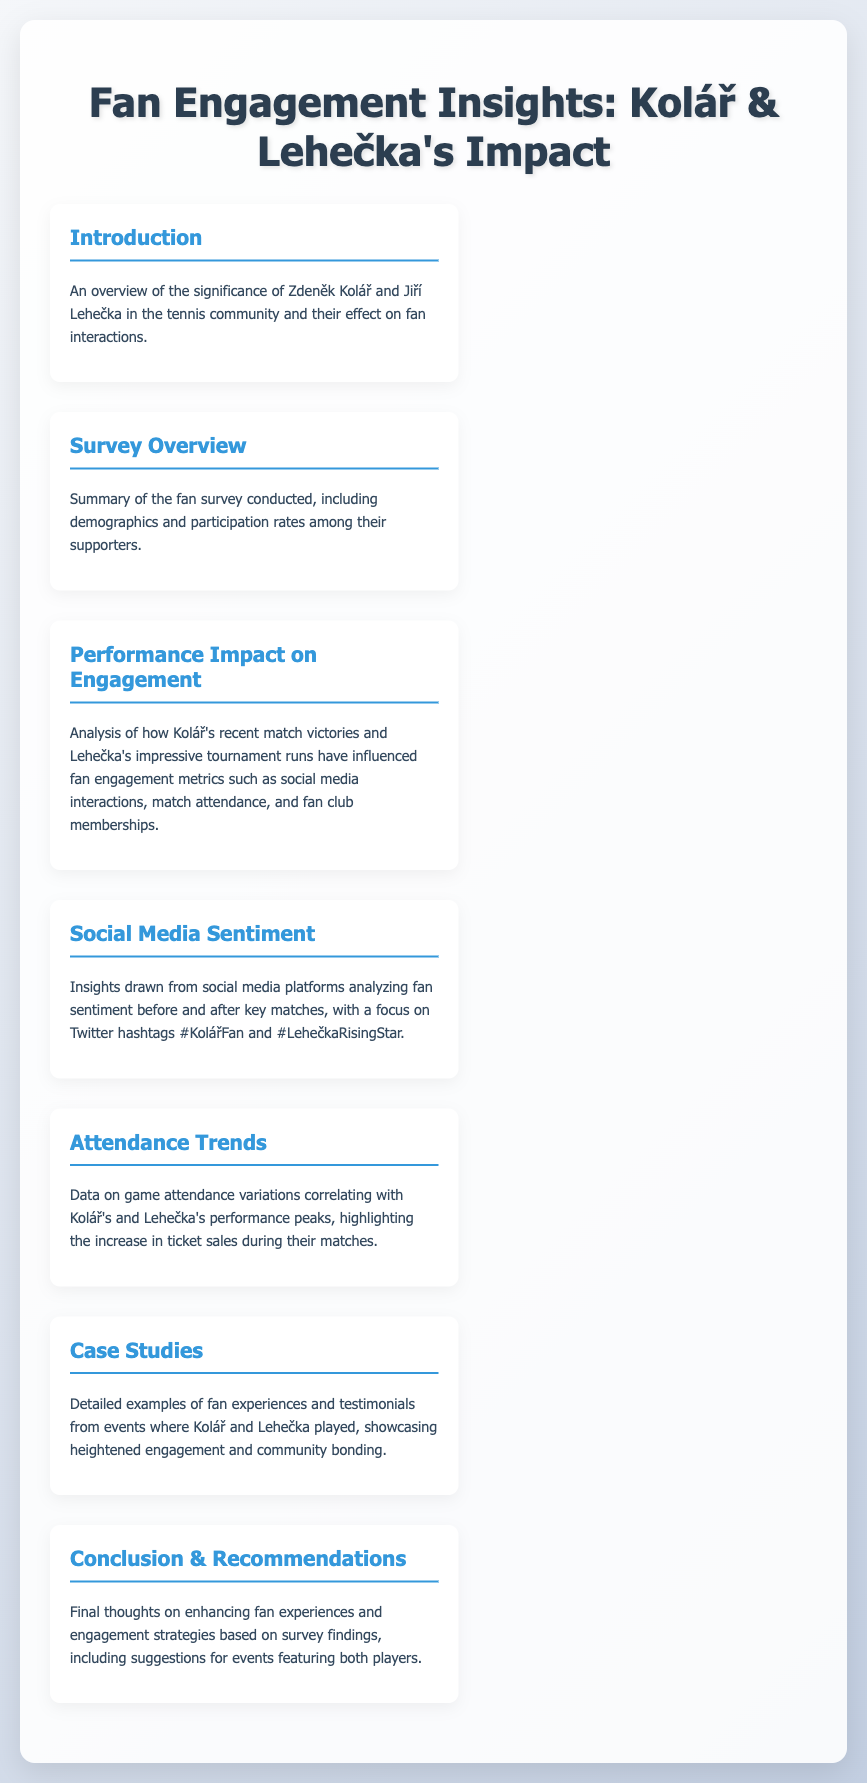What is the title of the report? The title of the report is given in the first heading of the document.
Answer: Fan Engagement Insights: Kolář & Lehečka's Impact Who are the two players focused on in the report? The report specifically highlights the significance of Zdeněk Kolář and Jiří Lehečka in the tennis community.
Answer: Zdeněk Kolář and Jiří Lehečka What is one of the key analyses in the document? The section titled "Performance Impact on Engagement" discusses how players' performances influence fan engagement metrics.
Answer: Performance Impact on Engagement Which social media platforms were analyzed for sentiment? The report mentions Twitter as the primary platform for analyzing fan sentiment regarding the players.
Answer: Twitter What type of insights are provided in the "Case Studies" section? This section includes testimonials from fans, showcasing experiences during events involving the players.
Answer: Testimonials from fans What is the content of the "Conclusion & Recommendations" section? This section suggests enhancing fan experiences and engagement strategies based on survey findings.
Answer: Enhancing fan experiences and engagement strategies What type of data is included in the "Attendance Trends" section? The "Attendance Trends" section includes data on game attendance variations correlating with players' performance.
Answer: Game attendance variations What are the hashtags mentioned for social media sentiment? Two hashtags analyzed for sentiment regarding the players are provided in the document.
Answer: #KolářFan and #LehečkaRisingStar 